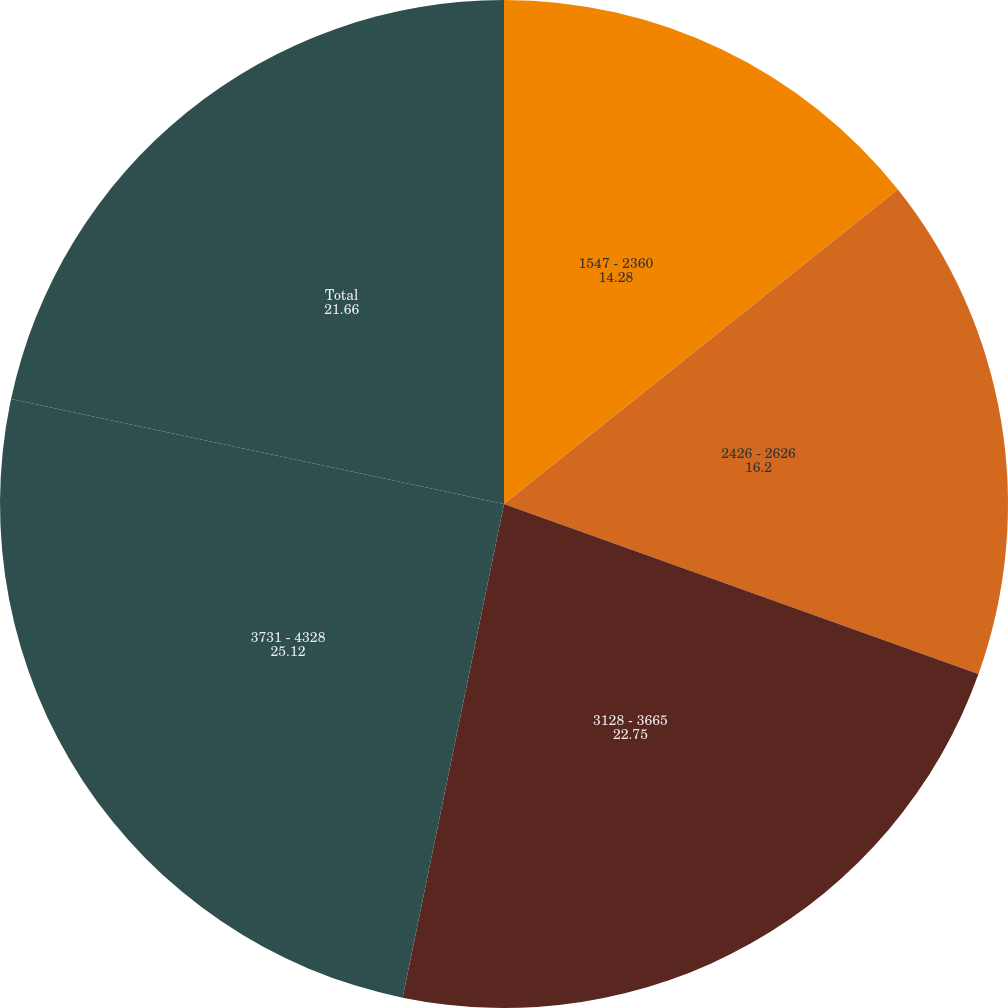<chart> <loc_0><loc_0><loc_500><loc_500><pie_chart><fcel>1547 - 2360<fcel>2426 - 2626<fcel>3128 - 3665<fcel>3731 - 4328<fcel>Total<nl><fcel>14.28%<fcel>16.2%<fcel>22.75%<fcel>25.12%<fcel>21.66%<nl></chart> 